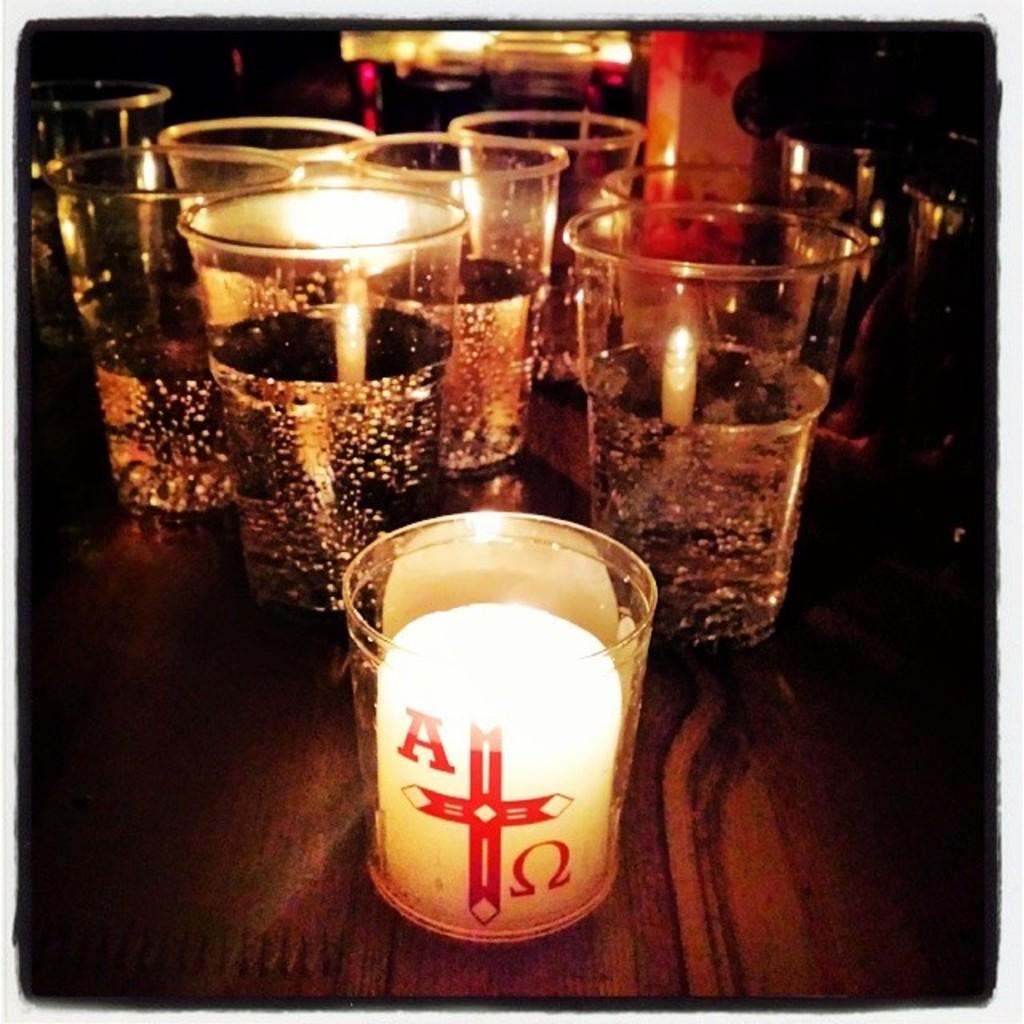What letter is seen on the glass?
Your answer should be compact. A. 